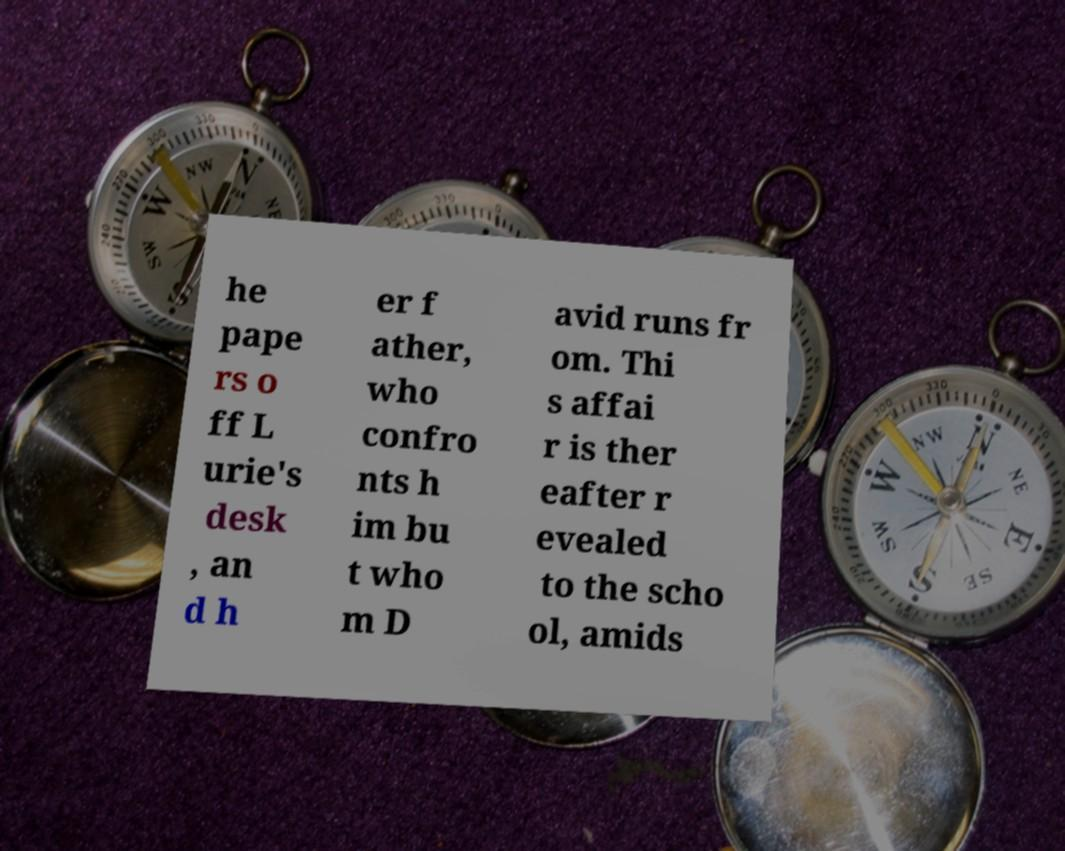Please identify and transcribe the text found in this image. he pape rs o ff L urie's desk , an d h er f ather, who confro nts h im bu t who m D avid runs fr om. Thi s affai r is ther eafter r evealed to the scho ol, amids 